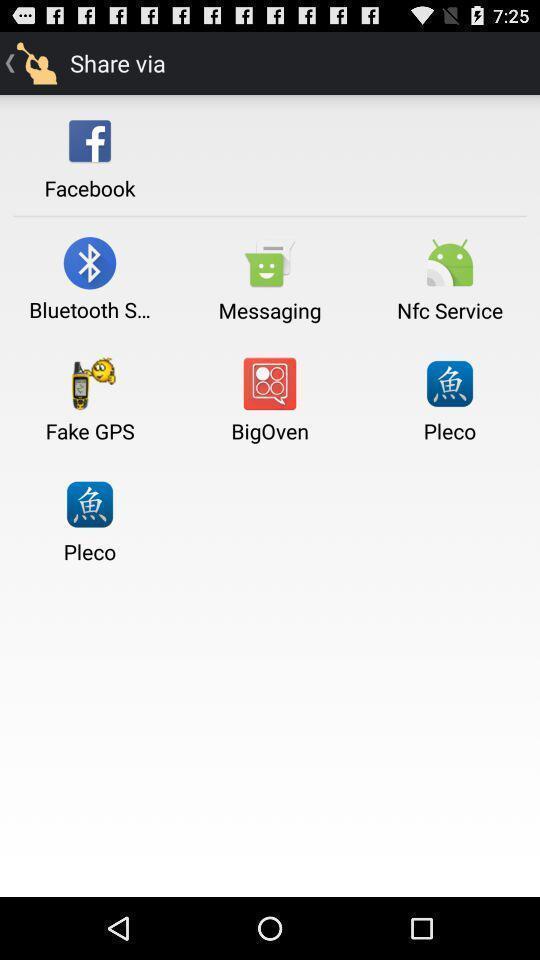What can you discern from this picture? Screen shows to share via other apps. 